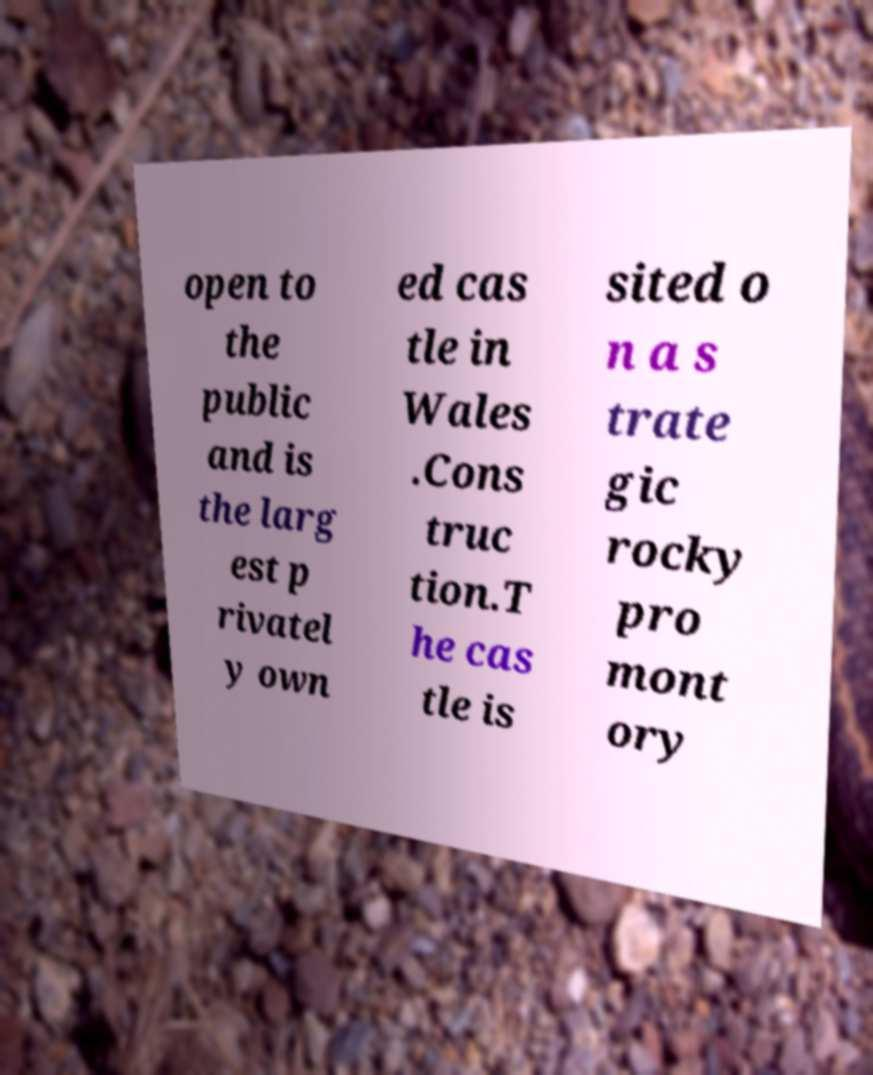Please identify and transcribe the text found in this image. open to the public and is the larg est p rivatel y own ed cas tle in Wales .Cons truc tion.T he cas tle is sited o n a s trate gic rocky pro mont ory 